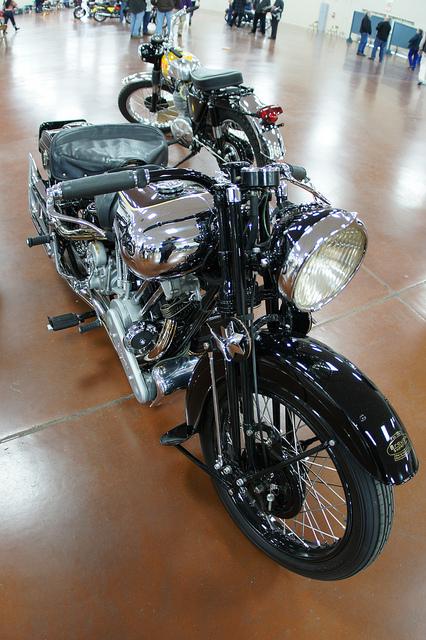What type of transportation is shown?
Give a very brief answer. Motorcycle. Is this bike outside?
Short answer required. No. What type of floor is this?
Short answer required. Cement. 